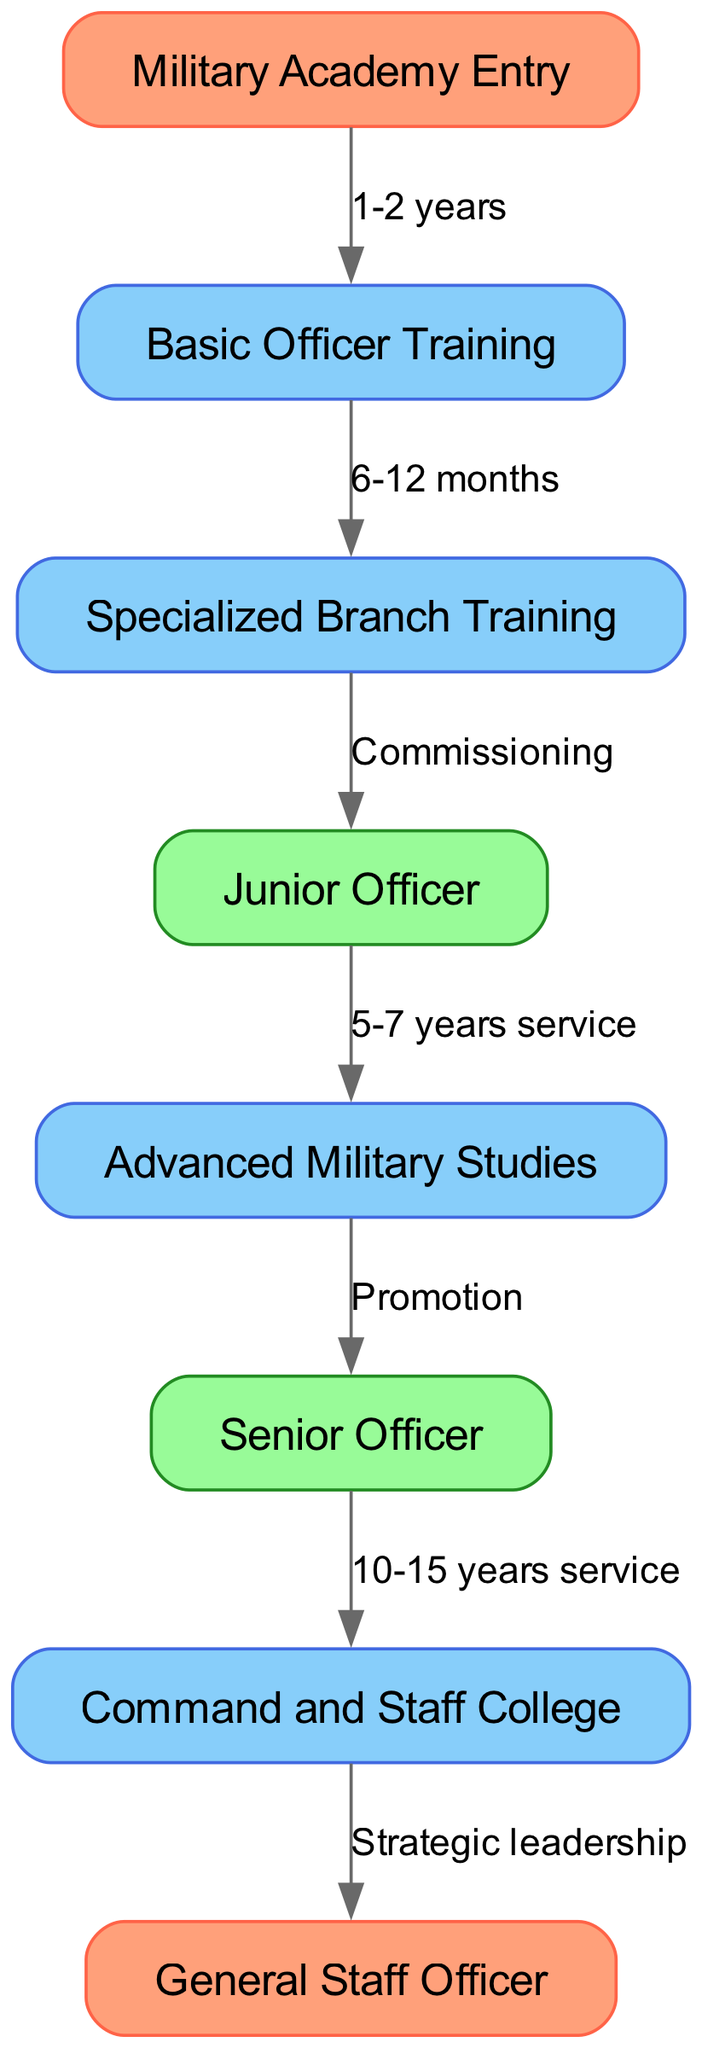What is the first stage of officer training? The diagram clearly indicates that the first stage of officer training is "Military Academy Entry".
Answer: Military Academy Entry How many training stages are there before becoming a Junior Officer? To determine the number of training stages before becoming a Junior Officer, we count the nodes connected to the "Junior Officer" node. There are three stages: "Basic Officer Training", "Specialized Branch Training", and finally "Junior Officer".
Answer: 3 What is the duration of Basic Officer Training? By examining the edge connected to the "Basic Officer Training" node, it shows that the duration is "1-2 years".
Answer: 1-2 years What rank is attained after completing Advanced Military Studies? The edge labeled "Promotion" from "Advanced Military Studies" leads to the "Senior Officer" node, indicating that after completing Advanced Military Studies, the rank attained is Senior Officer.
Answer: Senior Officer How long does it typically take to go from a Senior Officer to attending the Command and Staff College? The diagram specifies that after "10-15 years service" as a Senior Officer, one can attend the "Command and Staff College".
Answer: 10-15 years service What marked the transition from Specialized Branch Training to becoming a Junior Officer? The diagram indicates that the transition from "Specialized Branch Training" to "Junior Officer" occurs at the "Commissioning" node, which signifies the official commissioning process into the officer role.
Answer: Commissioning What color represents the training stages in the diagram? By observing the color scheme of the nodes, it is noted that the training stages are represented by the color "#87CEFA".
Answer: #87CEFA How many total edges are there in the diagram? By counting the connections (edges) between the nodes, we can see there are a total of seven edges representing the relationships between the various stages and ranks.
Answer: 7 